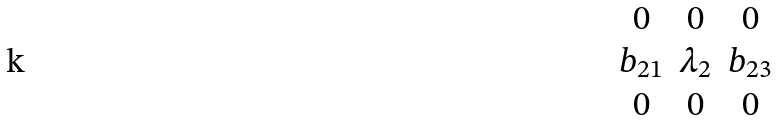Convert formula to latex. <formula><loc_0><loc_0><loc_500><loc_500>\begin{matrix} 0 & 0 & 0 \\ b _ { 2 1 } & \lambda _ { 2 } & b _ { 2 3 } \\ 0 & 0 & 0 \end{matrix}</formula> 